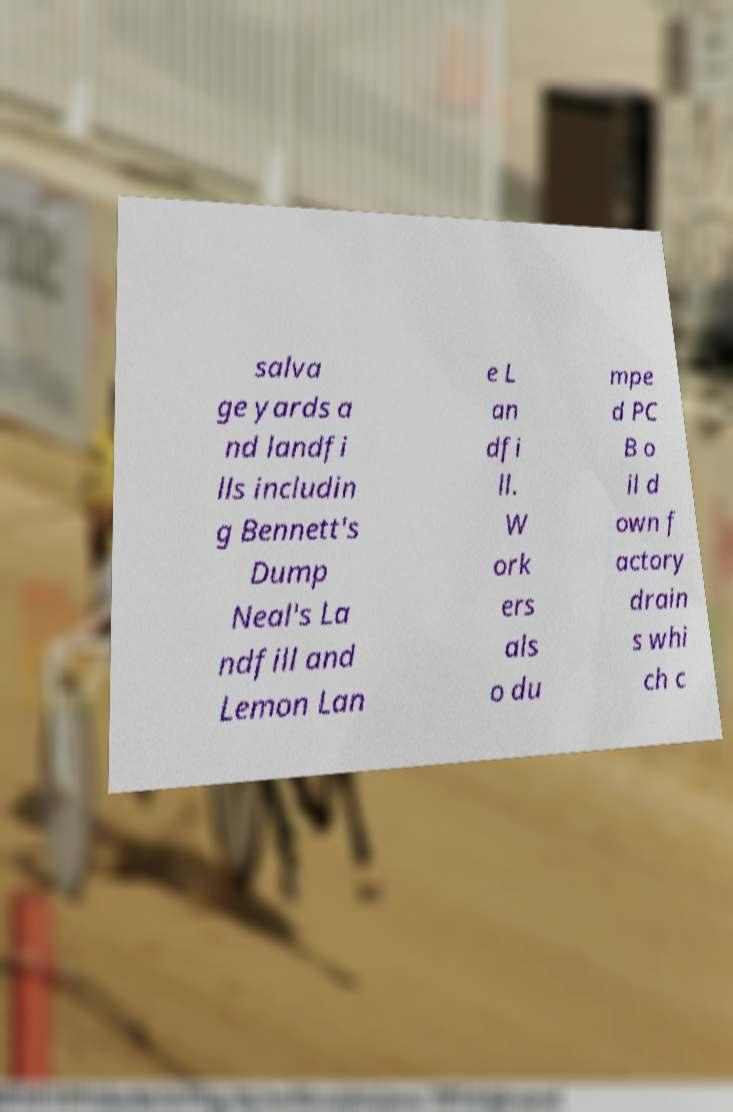What messages or text are displayed in this image? I need them in a readable, typed format. salva ge yards a nd landfi lls includin g Bennett's Dump Neal's La ndfill and Lemon Lan e L an dfi ll. W ork ers als o du mpe d PC B o il d own f actory drain s whi ch c 